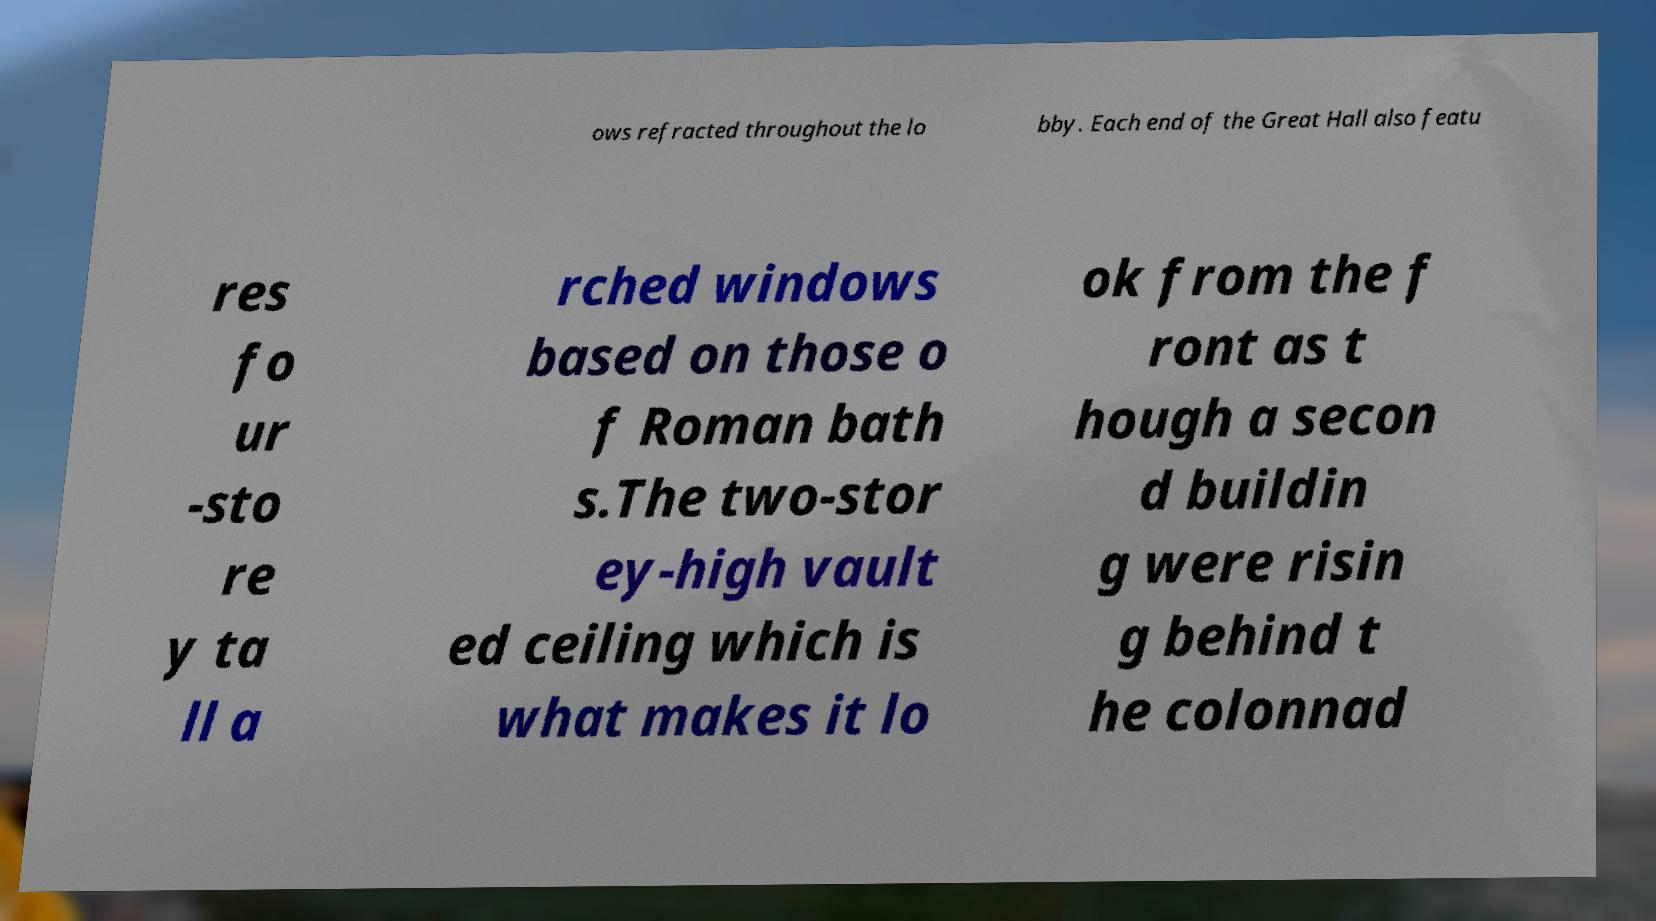What messages or text are displayed in this image? I need them in a readable, typed format. ows refracted throughout the lo bby. Each end of the Great Hall also featu res fo ur -sto re y ta ll a rched windows based on those o f Roman bath s.The two-stor ey-high vault ed ceiling which is what makes it lo ok from the f ront as t hough a secon d buildin g were risin g behind t he colonnad 